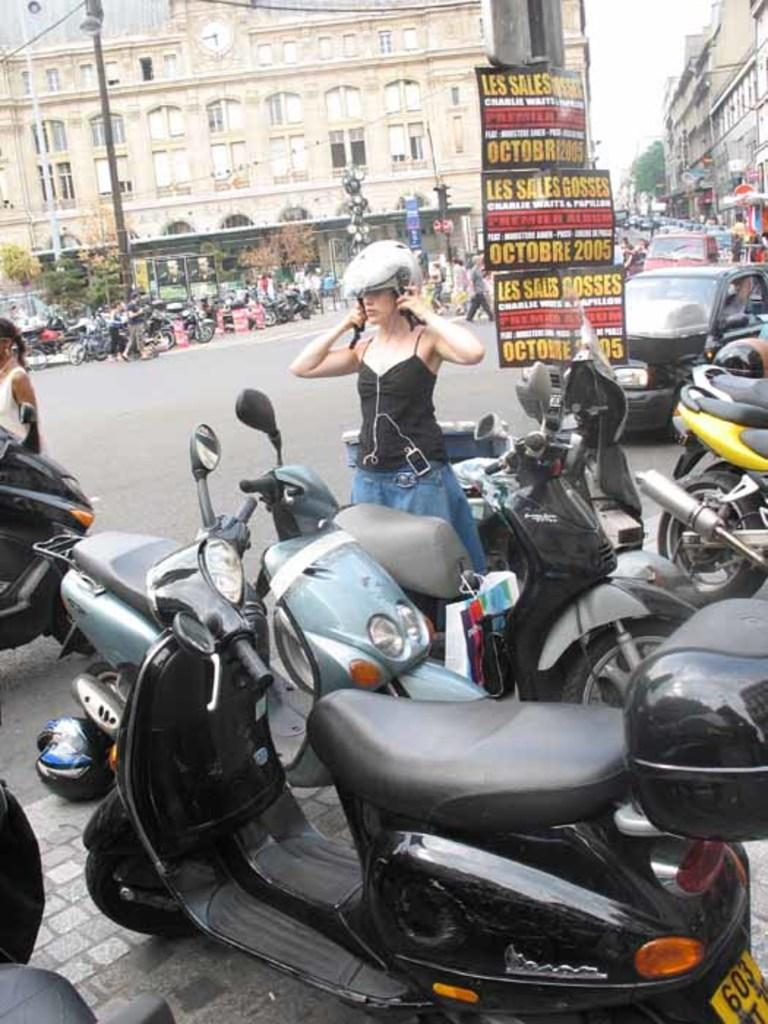What is the main subject of the image? There is a beautiful woman in the image. What is the woman doing in the image? The woman is standing near a Scooty and adjusting her helmet. What is the woman wearing in the image? The woman is wearing a black top. What can be seen in the background of the image? There is a big building in the image. What type of scarf is the woman wearing in the image? The woman is not wearing a scarf in the image; she is adjusting her helmet. How many mines are visible in the image? There are no mines present in the image. 